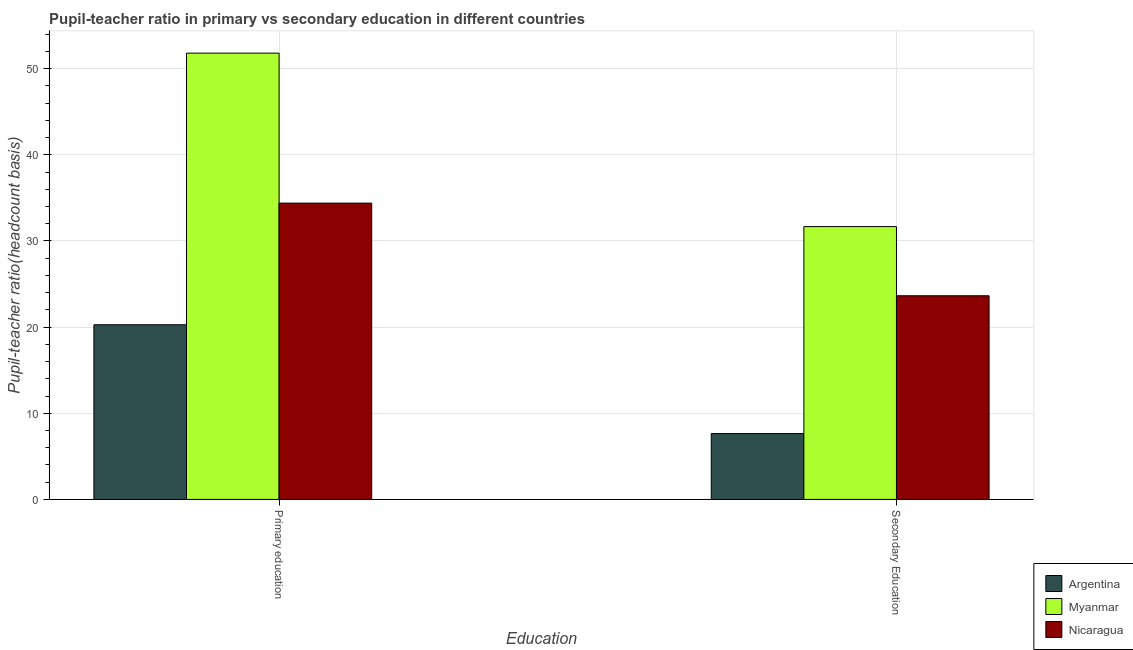How many bars are there on the 1st tick from the right?
Keep it short and to the point. 3. What is the pupil-teacher ratio in primary education in Nicaragua?
Your response must be concise. 34.4. Across all countries, what is the maximum pupil-teacher ratio in primary education?
Give a very brief answer. 51.81. Across all countries, what is the minimum pupil teacher ratio on secondary education?
Ensure brevity in your answer.  7.64. In which country was the pupil teacher ratio on secondary education maximum?
Your response must be concise. Myanmar. What is the total pupil-teacher ratio in primary education in the graph?
Ensure brevity in your answer.  106.48. What is the difference between the pupil teacher ratio on secondary education in Myanmar and that in Argentina?
Provide a short and direct response. 24.03. What is the difference between the pupil teacher ratio on secondary education in Nicaragua and the pupil-teacher ratio in primary education in Myanmar?
Make the answer very short. -28.16. What is the average pupil teacher ratio on secondary education per country?
Give a very brief answer. 20.99. What is the difference between the pupil teacher ratio on secondary education and pupil-teacher ratio in primary education in Argentina?
Provide a short and direct response. -12.63. In how many countries, is the pupil teacher ratio on secondary education greater than 42 ?
Your response must be concise. 0. What is the ratio of the pupil teacher ratio on secondary education in Argentina to that in Nicaragua?
Your answer should be very brief. 0.32. Is the pupil teacher ratio on secondary education in Argentina less than that in Nicaragua?
Provide a succinct answer. Yes. What does the 2nd bar from the right in Secondary Education represents?
Your answer should be compact. Myanmar. Are the values on the major ticks of Y-axis written in scientific E-notation?
Provide a short and direct response. No. How are the legend labels stacked?
Your answer should be compact. Vertical. What is the title of the graph?
Offer a terse response. Pupil-teacher ratio in primary vs secondary education in different countries. Does "Finland" appear as one of the legend labels in the graph?
Offer a very short reply. No. What is the label or title of the X-axis?
Keep it short and to the point. Education. What is the label or title of the Y-axis?
Ensure brevity in your answer.  Pupil-teacher ratio(headcount basis). What is the Pupil-teacher ratio(headcount basis) in Argentina in Primary education?
Your answer should be very brief. 20.28. What is the Pupil-teacher ratio(headcount basis) of Myanmar in Primary education?
Offer a very short reply. 51.81. What is the Pupil-teacher ratio(headcount basis) of Nicaragua in Primary education?
Ensure brevity in your answer.  34.4. What is the Pupil-teacher ratio(headcount basis) of Argentina in Secondary Education?
Make the answer very short. 7.64. What is the Pupil-teacher ratio(headcount basis) in Myanmar in Secondary Education?
Give a very brief answer. 31.67. What is the Pupil-teacher ratio(headcount basis) of Nicaragua in Secondary Education?
Your answer should be compact. 23.64. Across all Education, what is the maximum Pupil-teacher ratio(headcount basis) of Argentina?
Offer a very short reply. 20.28. Across all Education, what is the maximum Pupil-teacher ratio(headcount basis) of Myanmar?
Provide a succinct answer. 51.81. Across all Education, what is the maximum Pupil-teacher ratio(headcount basis) of Nicaragua?
Your answer should be very brief. 34.4. Across all Education, what is the minimum Pupil-teacher ratio(headcount basis) of Argentina?
Give a very brief answer. 7.64. Across all Education, what is the minimum Pupil-teacher ratio(headcount basis) of Myanmar?
Keep it short and to the point. 31.67. Across all Education, what is the minimum Pupil-teacher ratio(headcount basis) of Nicaragua?
Keep it short and to the point. 23.64. What is the total Pupil-teacher ratio(headcount basis) of Argentina in the graph?
Offer a very short reply. 27.92. What is the total Pupil-teacher ratio(headcount basis) of Myanmar in the graph?
Your answer should be compact. 83.48. What is the total Pupil-teacher ratio(headcount basis) of Nicaragua in the graph?
Provide a short and direct response. 58.04. What is the difference between the Pupil-teacher ratio(headcount basis) of Argentina in Primary education and that in Secondary Education?
Your response must be concise. 12.63. What is the difference between the Pupil-teacher ratio(headcount basis) of Myanmar in Primary education and that in Secondary Education?
Your answer should be compact. 20.14. What is the difference between the Pupil-teacher ratio(headcount basis) in Nicaragua in Primary education and that in Secondary Education?
Make the answer very short. 10.75. What is the difference between the Pupil-teacher ratio(headcount basis) of Argentina in Primary education and the Pupil-teacher ratio(headcount basis) of Myanmar in Secondary Education?
Your answer should be compact. -11.4. What is the difference between the Pupil-teacher ratio(headcount basis) in Argentina in Primary education and the Pupil-teacher ratio(headcount basis) in Nicaragua in Secondary Education?
Your answer should be compact. -3.37. What is the difference between the Pupil-teacher ratio(headcount basis) of Myanmar in Primary education and the Pupil-teacher ratio(headcount basis) of Nicaragua in Secondary Education?
Offer a terse response. 28.16. What is the average Pupil-teacher ratio(headcount basis) in Argentina per Education?
Ensure brevity in your answer.  13.96. What is the average Pupil-teacher ratio(headcount basis) of Myanmar per Education?
Provide a short and direct response. 41.74. What is the average Pupil-teacher ratio(headcount basis) in Nicaragua per Education?
Your answer should be compact. 29.02. What is the difference between the Pupil-teacher ratio(headcount basis) in Argentina and Pupil-teacher ratio(headcount basis) in Myanmar in Primary education?
Your response must be concise. -31.53. What is the difference between the Pupil-teacher ratio(headcount basis) of Argentina and Pupil-teacher ratio(headcount basis) of Nicaragua in Primary education?
Your answer should be compact. -14.12. What is the difference between the Pupil-teacher ratio(headcount basis) of Myanmar and Pupil-teacher ratio(headcount basis) of Nicaragua in Primary education?
Ensure brevity in your answer.  17.41. What is the difference between the Pupil-teacher ratio(headcount basis) in Argentina and Pupil-teacher ratio(headcount basis) in Myanmar in Secondary Education?
Your response must be concise. -24.03. What is the difference between the Pupil-teacher ratio(headcount basis) in Argentina and Pupil-teacher ratio(headcount basis) in Nicaragua in Secondary Education?
Your response must be concise. -16. What is the difference between the Pupil-teacher ratio(headcount basis) in Myanmar and Pupil-teacher ratio(headcount basis) in Nicaragua in Secondary Education?
Provide a short and direct response. 8.03. What is the ratio of the Pupil-teacher ratio(headcount basis) in Argentina in Primary education to that in Secondary Education?
Give a very brief answer. 2.65. What is the ratio of the Pupil-teacher ratio(headcount basis) in Myanmar in Primary education to that in Secondary Education?
Ensure brevity in your answer.  1.64. What is the ratio of the Pupil-teacher ratio(headcount basis) of Nicaragua in Primary education to that in Secondary Education?
Provide a short and direct response. 1.45. What is the difference between the highest and the second highest Pupil-teacher ratio(headcount basis) of Argentina?
Offer a terse response. 12.63. What is the difference between the highest and the second highest Pupil-teacher ratio(headcount basis) of Myanmar?
Keep it short and to the point. 20.14. What is the difference between the highest and the second highest Pupil-teacher ratio(headcount basis) of Nicaragua?
Your response must be concise. 10.75. What is the difference between the highest and the lowest Pupil-teacher ratio(headcount basis) in Argentina?
Your answer should be very brief. 12.63. What is the difference between the highest and the lowest Pupil-teacher ratio(headcount basis) of Myanmar?
Provide a succinct answer. 20.14. What is the difference between the highest and the lowest Pupil-teacher ratio(headcount basis) of Nicaragua?
Your answer should be very brief. 10.75. 